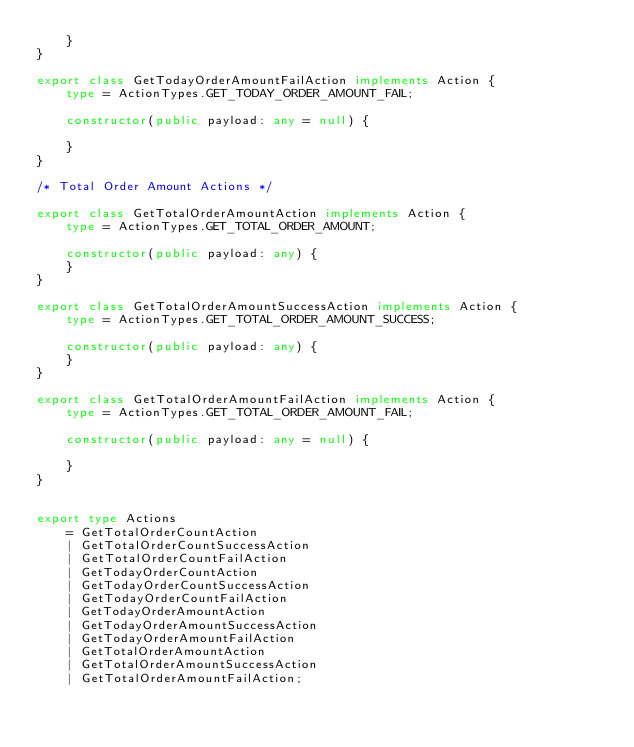Convert code to text. <code><loc_0><loc_0><loc_500><loc_500><_TypeScript_>    }
}

export class GetTodayOrderAmountFailAction implements Action {
    type = ActionTypes.GET_TODAY_ORDER_AMOUNT_FAIL;

    constructor(public payload: any = null) {

    }
}

/* Total Order Amount Actions */

export class GetTotalOrderAmountAction implements Action {
    type = ActionTypes.GET_TOTAL_ORDER_AMOUNT;

    constructor(public payload: any) {
    }
}

export class GetTotalOrderAmountSuccessAction implements Action {
    type = ActionTypes.GET_TOTAL_ORDER_AMOUNT_SUCCESS;

    constructor(public payload: any) {
    }
}

export class GetTotalOrderAmountFailAction implements Action {
    type = ActionTypes.GET_TOTAL_ORDER_AMOUNT_FAIL;

    constructor(public payload: any = null) {

    }
}


export type Actions
    = GetTotalOrderCountAction
    | GetTotalOrderCountSuccessAction
    | GetTotalOrderCountFailAction
    | GetTodayOrderCountAction
    | GetTodayOrderCountSuccessAction
    | GetTodayOrderCountFailAction
    | GetTodayOrderAmountAction
    | GetTodayOrderAmountSuccessAction
    | GetTodayOrderAmountFailAction
    | GetTotalOrderAmountAction
    | GetTotalOrderAmountSuccessAction
    | GetTotalOrderAmountFailAction;

</code> 